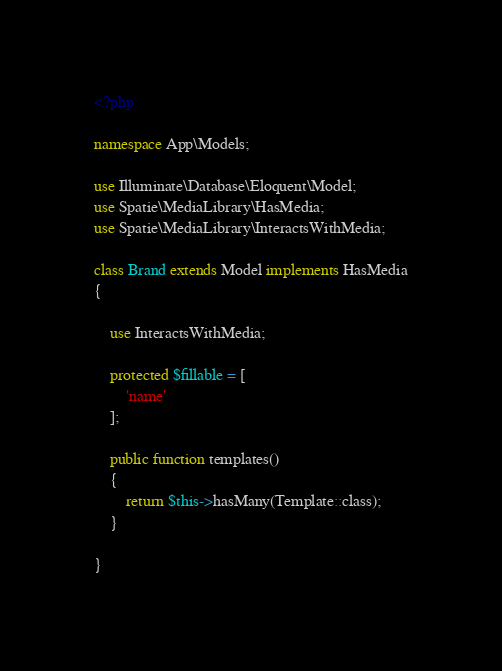<code> <loc_0><loc_0><loc_500><loc_500><_PHP_><?php

namespace App\Models;

use Illuminate\Database\Eloquent\Model;
use Spatie\MediaLibrary\HasMedia;
use Spatie\MediaLibrary\InteractsWithMedia;

class Brand extends Model implements HasMedia
{

    use InteractsWithMedia;

    protected $fillable = [
        'name'
    ];

    public function templates()
    {
        return $this->hasMany(Template::class);
    }

}
</code> 